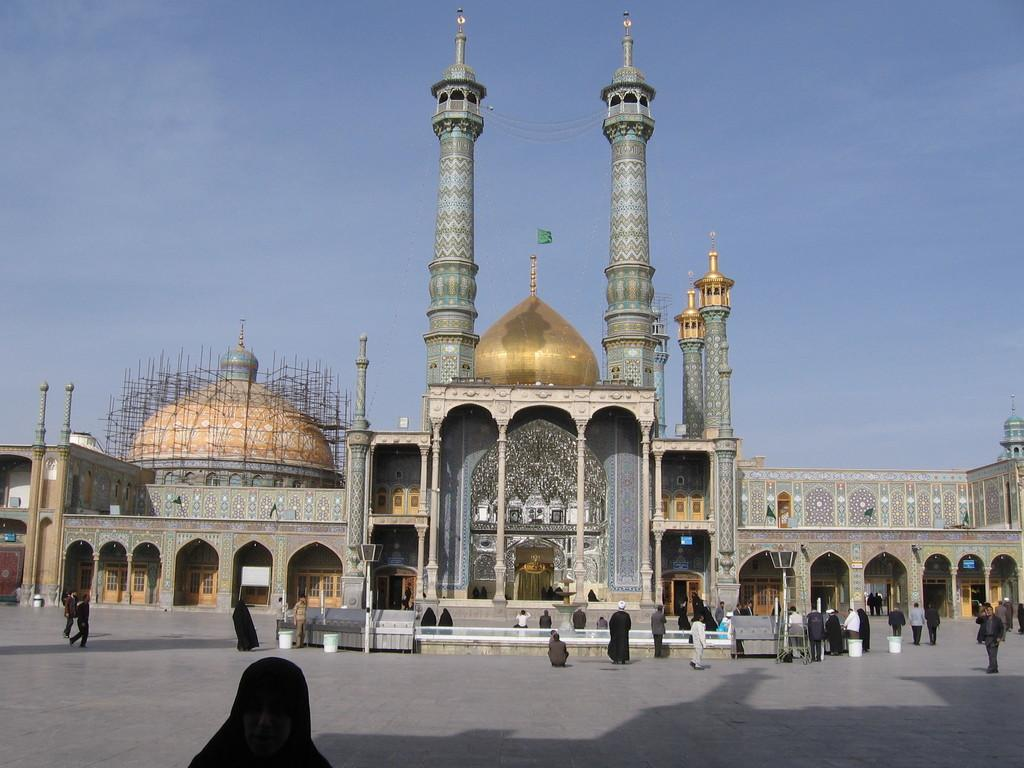Who or what can be seen in the image? There are people in the image. What else is present at the bottom of the image? There are other objects at the bottom of the image. What structure is located in the middle of the image? There is a building in the middle of the image. What can be seen in the background of the image? The sky is visible in the background of the image. What type of chalk is being used by the people in the image? There is no chalk present in the image, and therefore no such activity can be observed. 